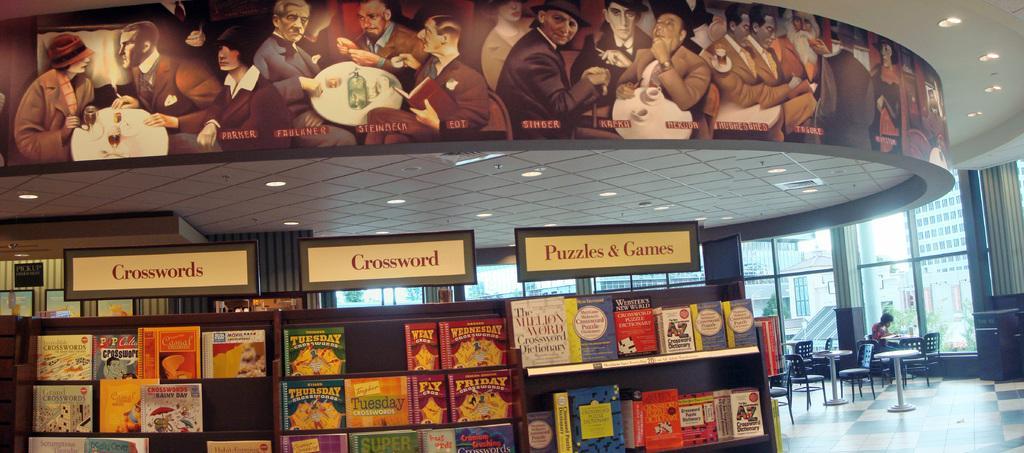Please provide a concise description of this image. At the bottom of the picture, we see a rack in which books are placed. Above that, we see the boards in white color with some text written on it. On the right side, we see the man is sitting on the chair. In front of him, we see a table. There are many chairs and tables beside him. Behind him, we see the glass windows from which we can see many buildings and trees. At the top, we see the hoarding board and the ceiling of the room. 